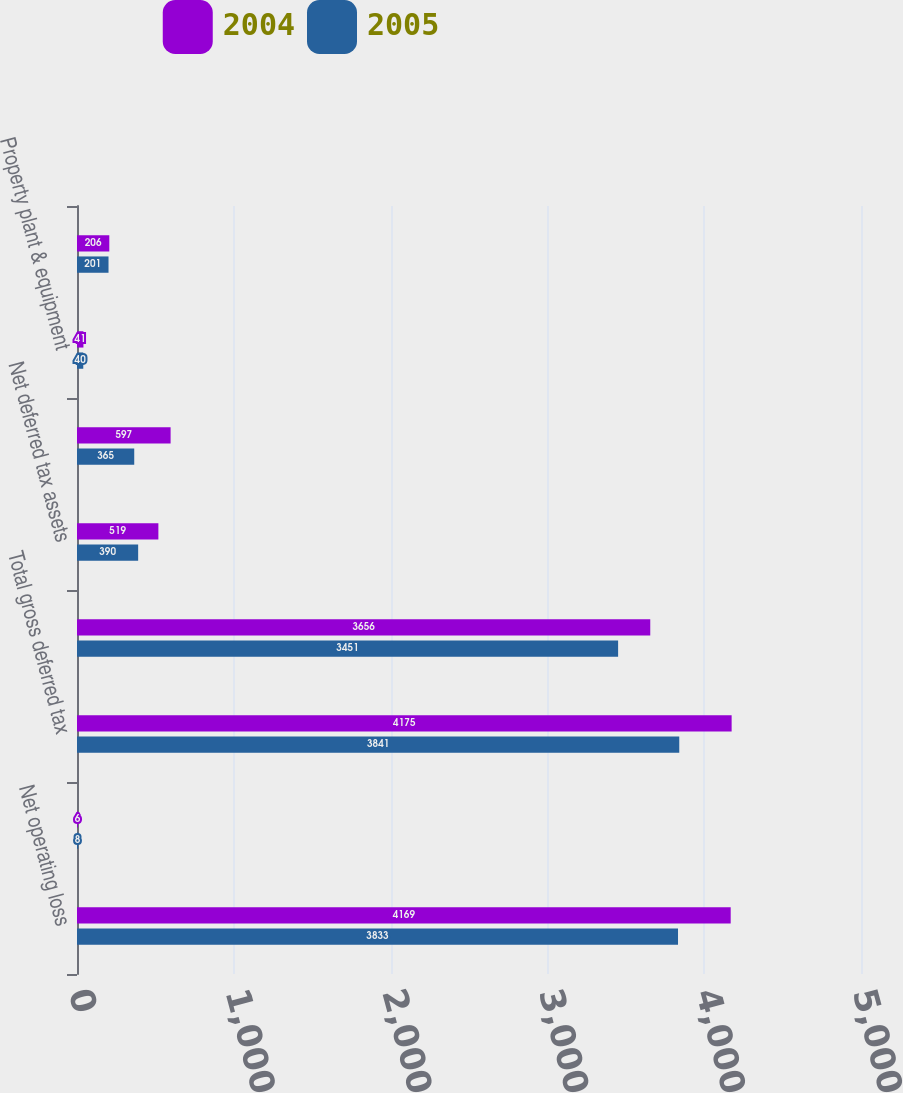Convert chart. <chart><loc_0><loc_0><loc_500><loc_500><stacked_bar_chart><ecel><fcel>Net operating loss<fcel>Other<fcel>Total gross deferred tax<fcel>Less valuation allowance<fcel>Net deferred tax assets<fcel>Investment in Charter Holdco<fcel>Property plant & equipment<fcel>Franchises<nl><fcel>2004<fcel>4169<fcel>6<fcel>4175<fcel>3656<fcel>519<fcel>597<fcel>41<fcel>206<nl><fcel>2005<fcel>3833<fcel>8<fcel>3841<fcel>3451<fcel>390<fcel>365<fcel>40<fcel>201<nl></chart> 